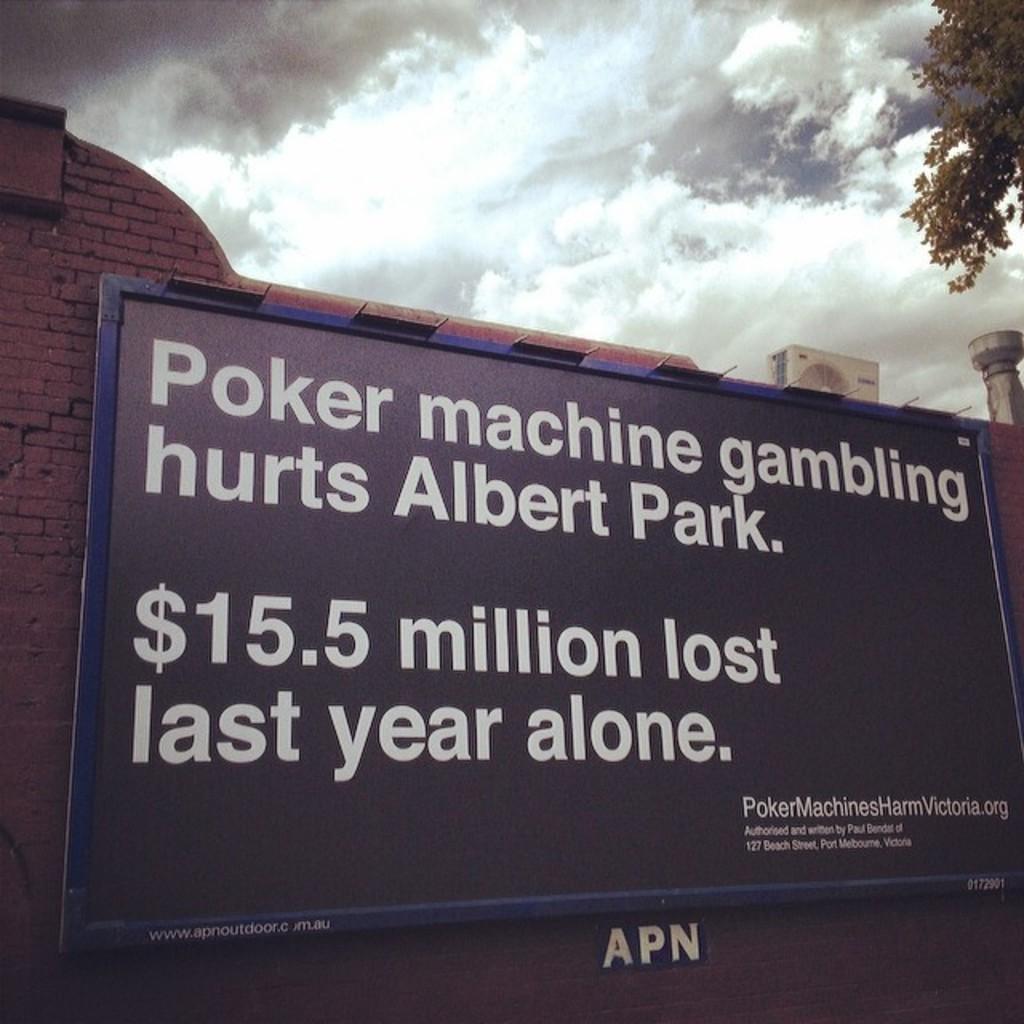What hurts albert park?
Offer a terse response. Poker machine gambling. How much money was lost last year?
Your answer should be compact. $15.5 million. 